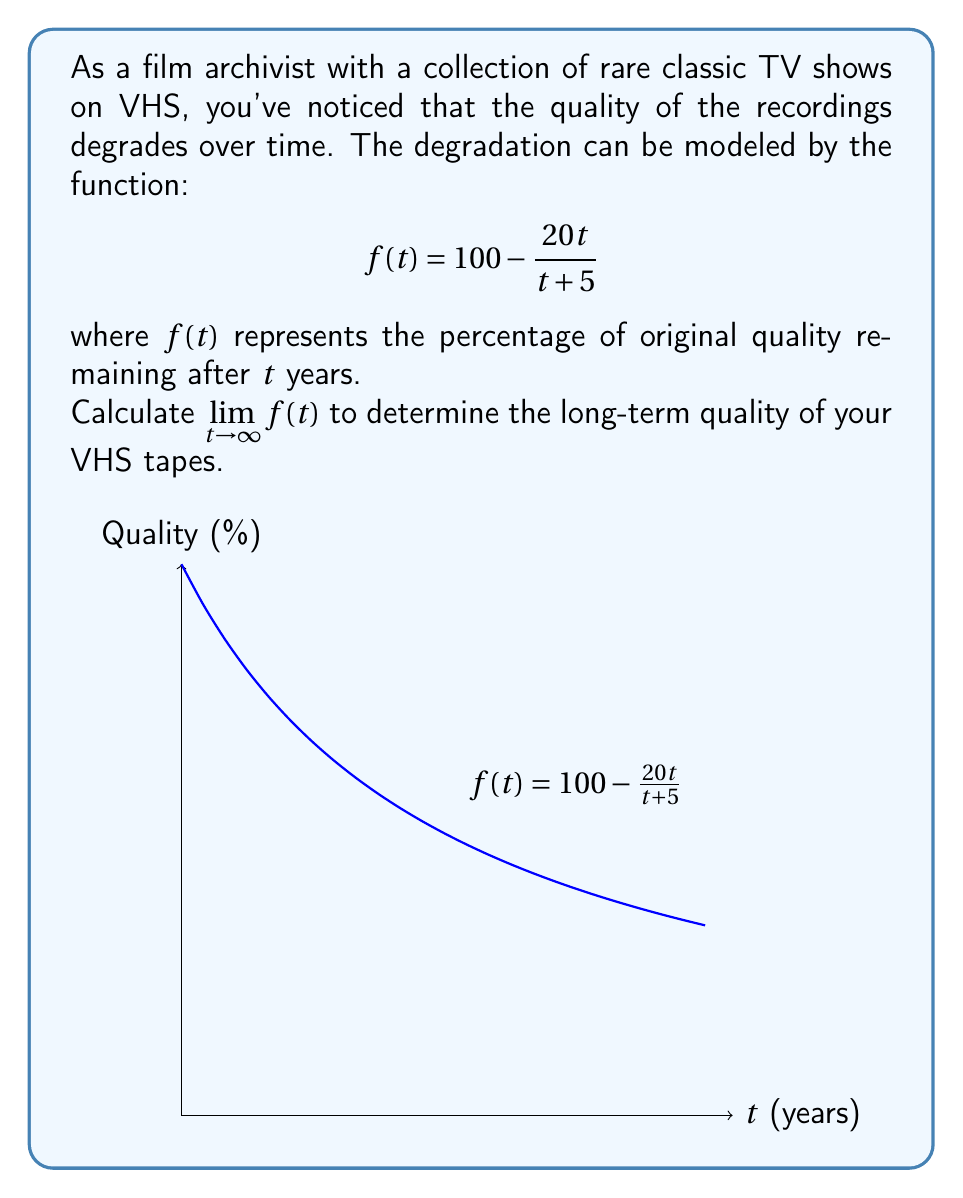What is the answer to this math problem? To calculate $\lim_{t \to \infty} f(t)$, let's follow these steps:

1) First, let's rewrite the function:
   $$f(t) = 100 - \frac{20t}{t+5}$$

2) As $t$ approaches infinity, both the numerator and denominator of the fraction will grow large. We can use the technique of dividing both the numerator and denominator by the highest power of $t$:

   $$\lim_{t \to \infty} f(t) = 100 - \lim_{t \to \infty} \frac{20t}{t+5}$$
   $$= 100 - \lim_{t \to \infty} \frac{20t/t}{(t+5)/t}$$
   $$= 100 - \lim_{t \to \infty} \frac{20}{1+5/t}$$

3) As $t$ approaches infinity, $5/t$ approaches 0:

   $$= 100 - \frac{20}{1+0} = 100 - 20 = 80$$

Therefore, the limit of the function as $t$ approaches infinity is 80.
Answer: 80 